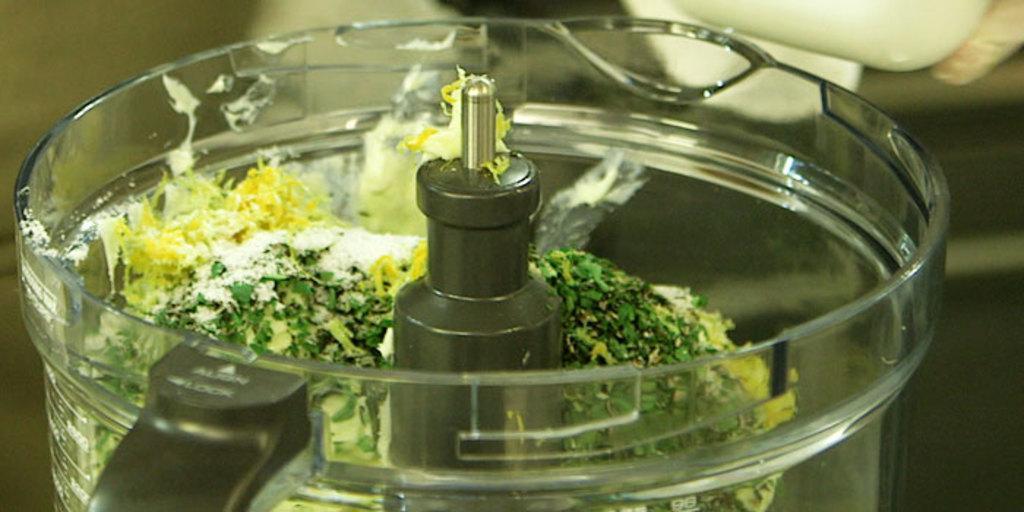Please provide a concise description of this image. This is a zoomed in picture. In the foreground there is a container containing some food items. In the background we can see some other items. 